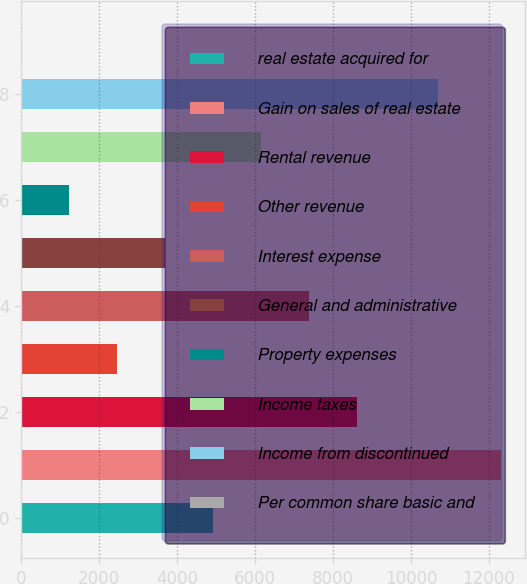Convert chart. <chart><loc_0><loc_0><loc_500><loc_500><bar_chart><fcel>real estate acquired for<fcel>Gain on sales of real estate<fcel>Rental revenue<fcel>Other revenue<fcel>Interest expense<fcel>General and administrative<fcel>Property expenses<fcel>Income taxes<fcel>Income from discontinued<fcel>Per common share basic and<nl><fcel>4927.67<fcel>12319<fcel>8623.34<fcel>2463.89<fcel>7391.45<fcel>3695.78<fcel>1232<fcel>6159.56<fcel>10703<fcel>0.11<nl></chart> 